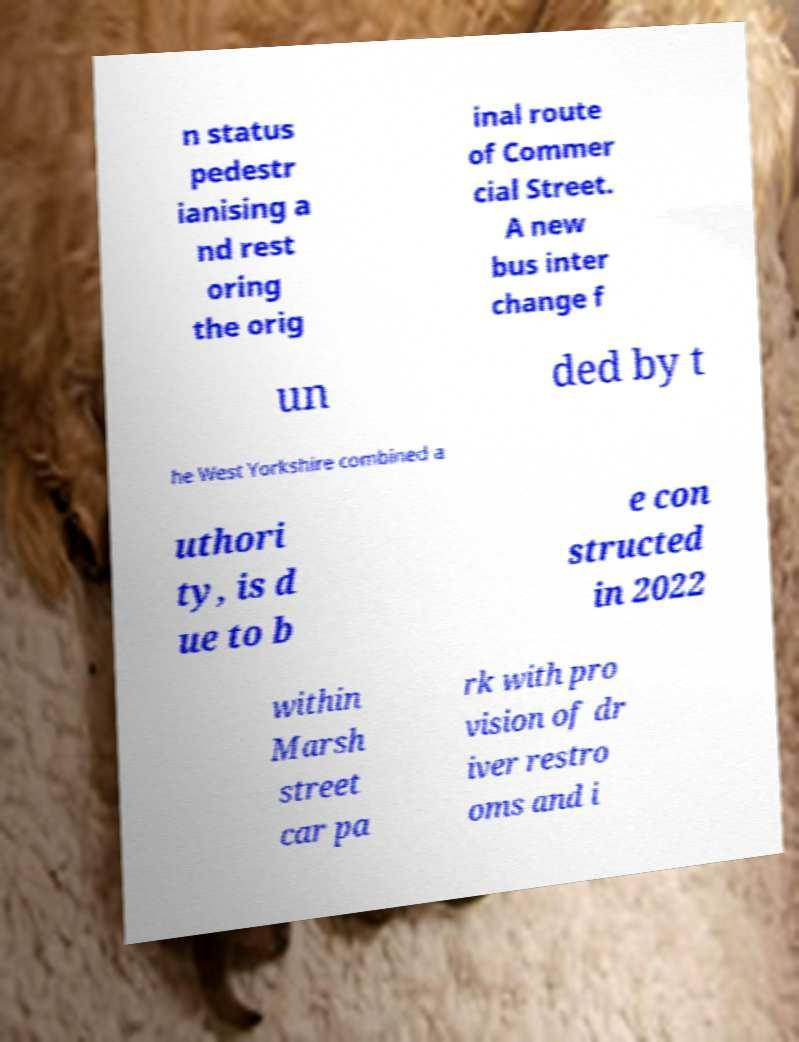I need the written content from this picture converted into text. Can you do that? n status pedestr ianising a nd rest oring the orig inal route of Commer cial Street. A new bus inter change f un ded by t he West Yorkshire combined a uthori ty, is d ue to b e con structed in 2022 within Marsh street car pa rk with pro vision of dr iver restro oms and i 